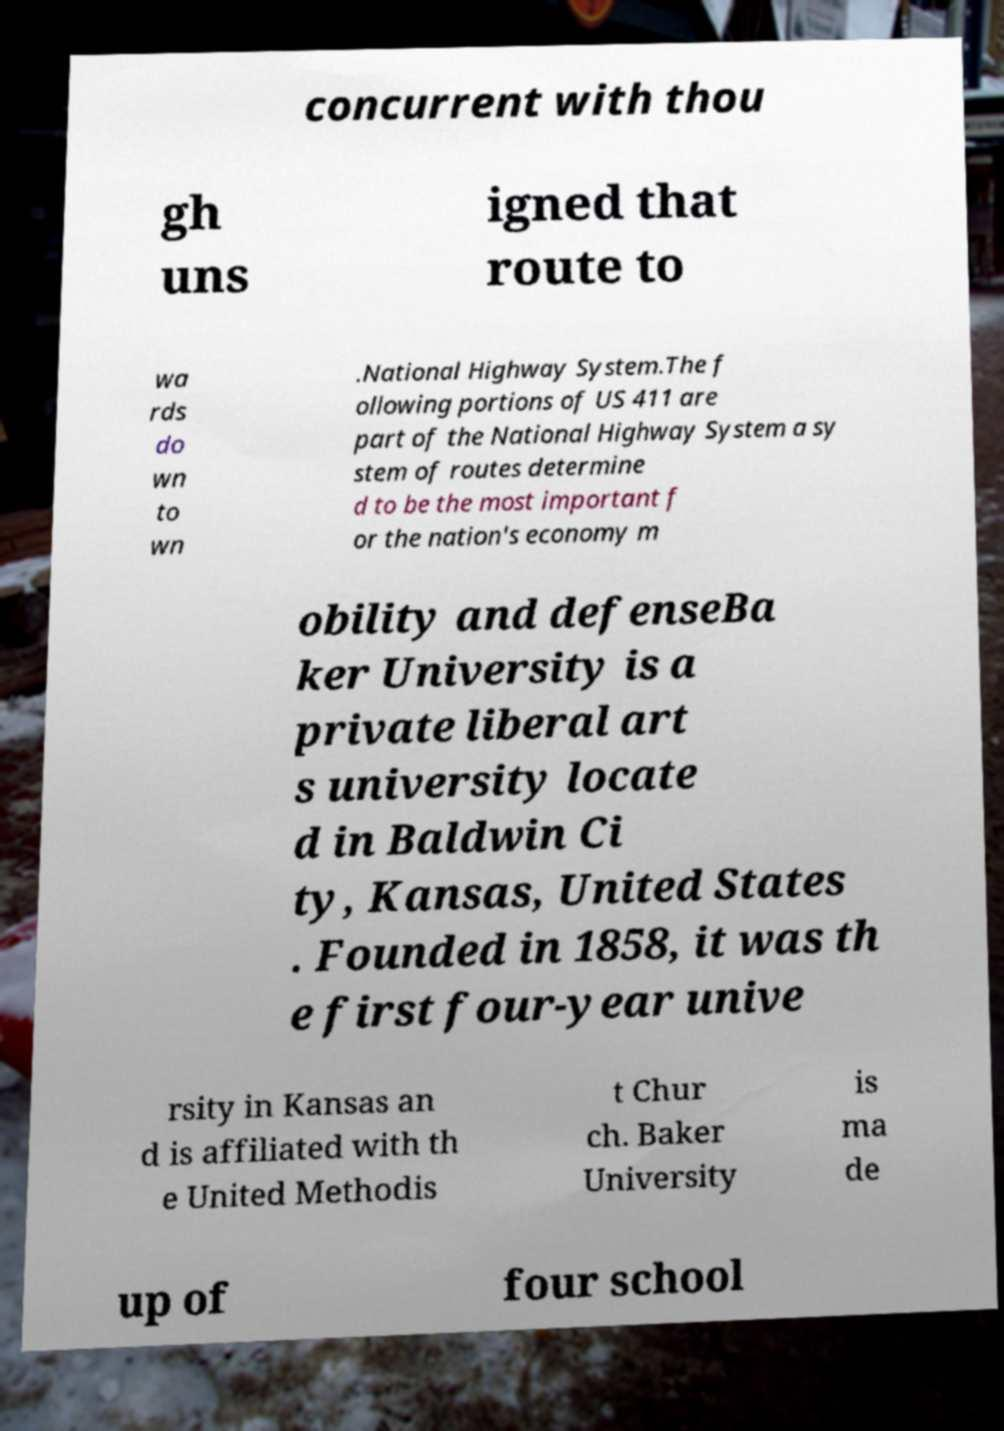What messages or text are displayed in this image? I need them in a readable, typed format. concurrent with thou gh uns igned that route to wa rds do wn to wn .National Highway System.The f ollowing portions of US 411 are part of the National Highway System a sy stem of routes determine d to be the most important f or the nation's economy m obility and defenseBa ker University is a private liberal art s university locate d in Baldwin Ci ty, Kansas, United States . Founded in 1858, it was th e first four-year unive rsity in Kansas an d is affiliated with th e United Methodis t Chur ch. Baker University is ma de up of four school 